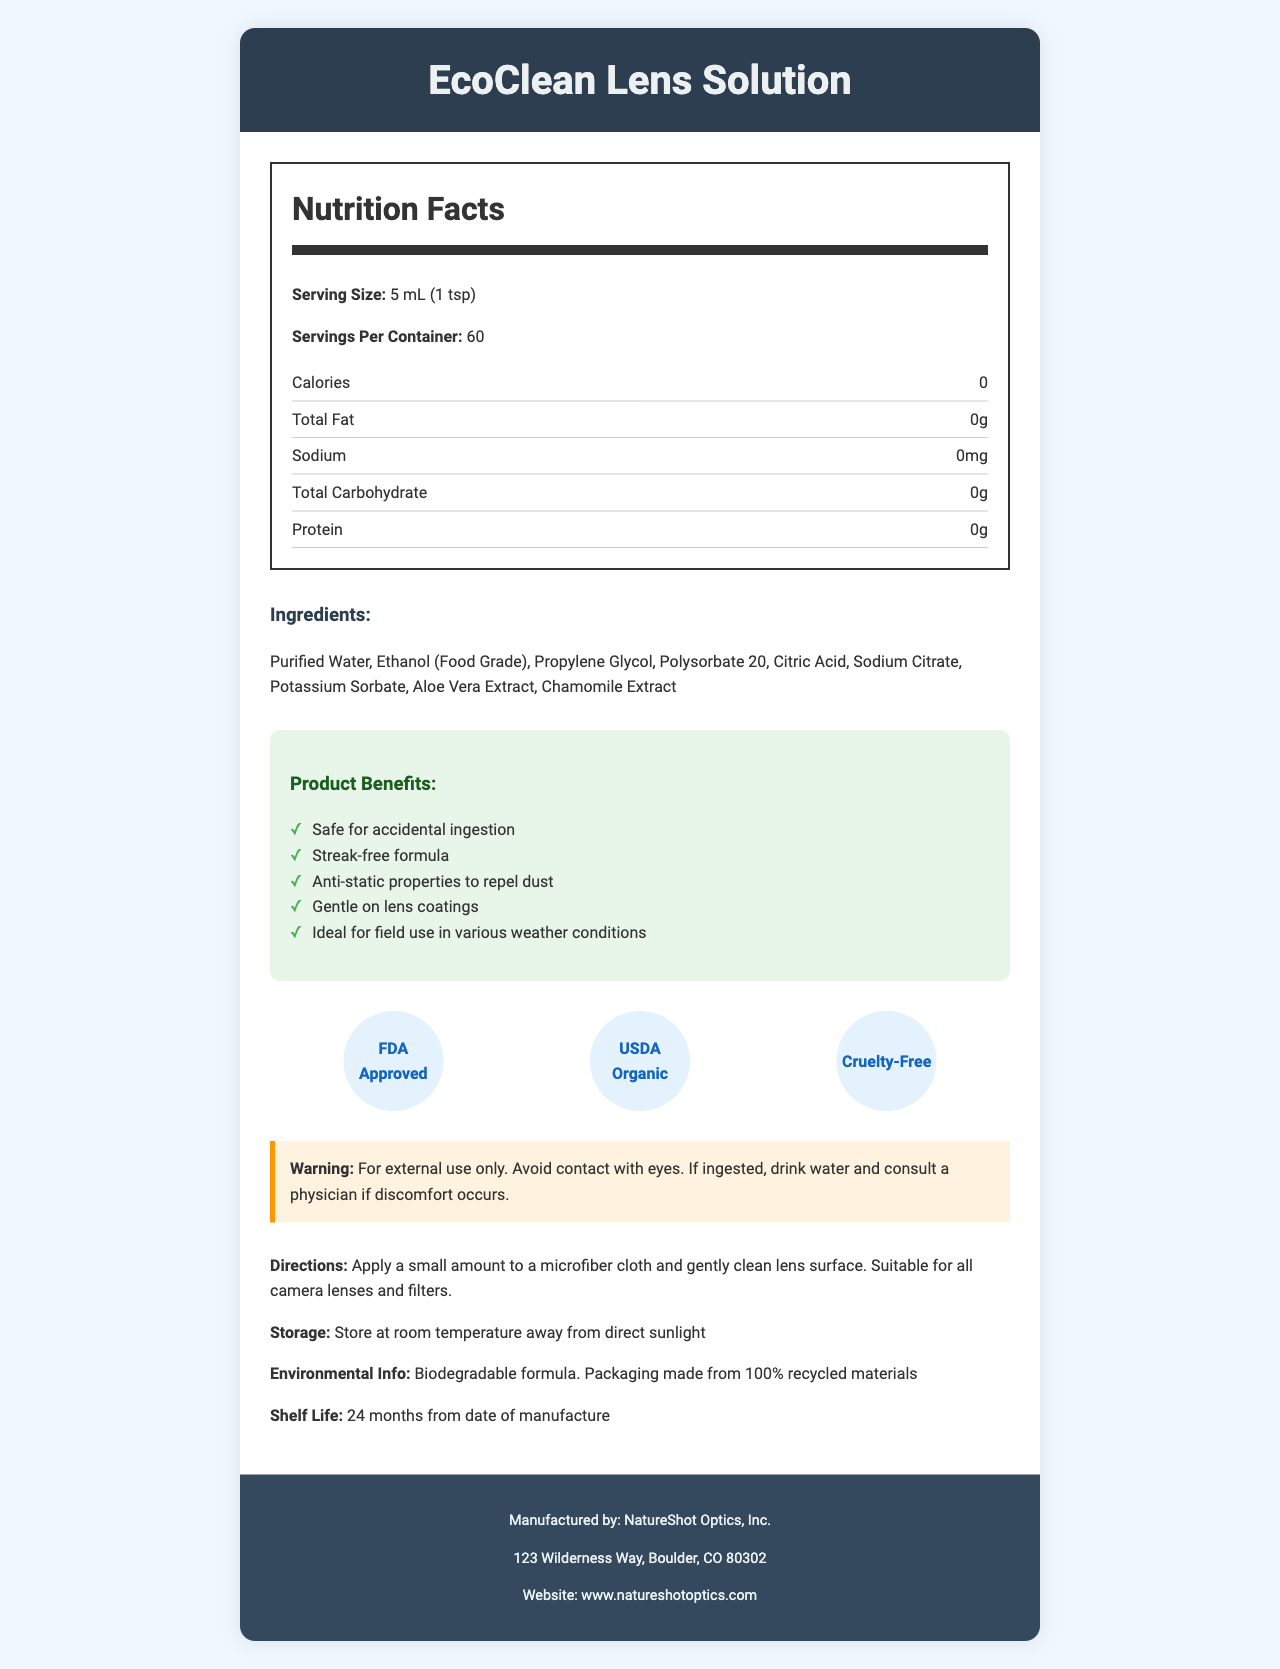what is the serving size of EcoClean Lens Solution? The document explicitly states that the serving size is 5 mL (1 tsp).
Answer: 5 mL (1 tsp) how many servings per container are there? The document states that there are 60 servings per container.
Answer: 60 what are the main ingredients in the EcoClean Lens Solution? The list of ingredients is provided in the ingredients section of the document.
Answer: Purified Water, Ethanol (Food Grade), Propylene Glycol, Polysorbate 20, Citric Acid, Sodium Citrate, Potassium Sorbate, Aloe Vera Extract, Chamomile Extract is EcoClean Lens Solution FDA approved? The document lists "FDA Approved" under the certifications section.
Answer: Yes can this product be ingested without harm? The product benefits section includes "Safe for accidental ingestion."
Answer: Safe for accidental ingestion what should you do if the product is ingested? The warning section advises to drink water and consult a physician if discomfort occurs in the case of ingestion.
Answer: Drink water and consult a physician if discomfort occurs what certifications does the product have? A. FDA Approved B. Non-GMO C. USDA Organic D. Eco-Certified The product is certified as "FDA Approved," "USDA Organic," and "Cruelty-Free," but it is not indicated to be Non-GMO or Eco-Certified.
Answer: A, C what is the shelf life of the product? A. 12 months B. 24 months C. 36 months D. 48 months The document states that the shelf life is 24 months from the date of manufacture.
Answer: B is this product suitable for cleaning all camera lenses and filters? The directions state that the solution is suitable for all camera lenses and filters.
Answer: Yes is the EcoClean Lens Solution environmentally friendly? The environmental info mentions that it has a biodegradable formula and the packaging is made from 100% recycled materials.
Answer: Yes how many calories are in one serving of the EcoClean Lens Solution? The nutrition facts section states that there are 0 calories per serving.
Answer: 0 where is the manufacturer located? The document provides the manufacturer's address.
Answer: 123 Wilderness Way, Boulder, CO 80302 does the EcoClean Lens Solution contain any allergens? The allergen information states that it contains no known allergens.
Answer: No which of the following is NOT an ingredient in the EcoClean Lens Solution? A. Citric Acid B. Aloe Vera Extract C. Chamomile Extract D. Menthol The ingredients list does not include Menthol.
Answer: D can you tell me more about the benefits of using this product? This information is found under the product benefits section.
Answer: The benefits include being safe for accidental ingestion, having a streak-free formula, anti-static properties to repel dust, being gentle on lens coatings, and being ideal for field use in various weather conditions. what should you avoid doing with this product? The warning section advises to avoid contact with eyes.
Answer: Avoid contact with eyes summarize the main idea of the document. This summary encapsulates the key points from all sections of the document.
Answer: The document provides detailed information about the EcoClean Lens Solution, including its nutritional facts, ingredients, benefits, certifications, usage directions, storage instructions, and warnings. The product is safe for accidental ingestion, biodegradable, and suitable for all camera lenses and filters. what is the production date of this product? The document provides the shelf life but does not mention the production date.
Answer: Cannot be determined 